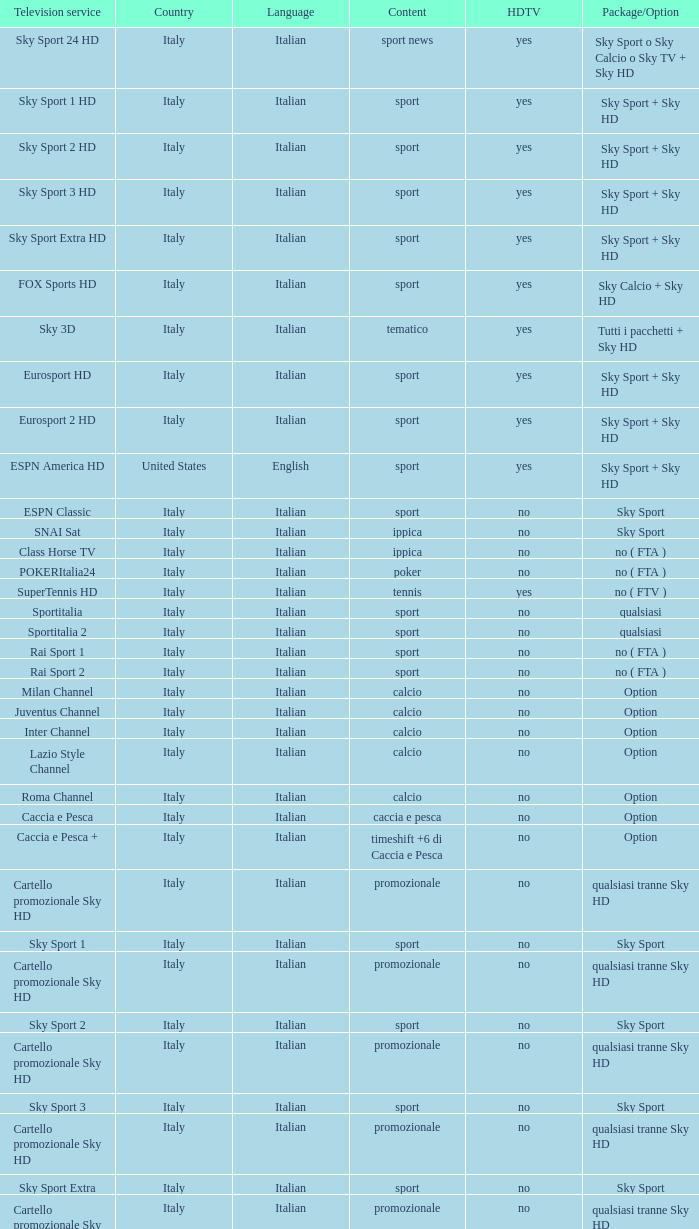What is Package/Option, when Content is Tennis? No ( ftv ). 